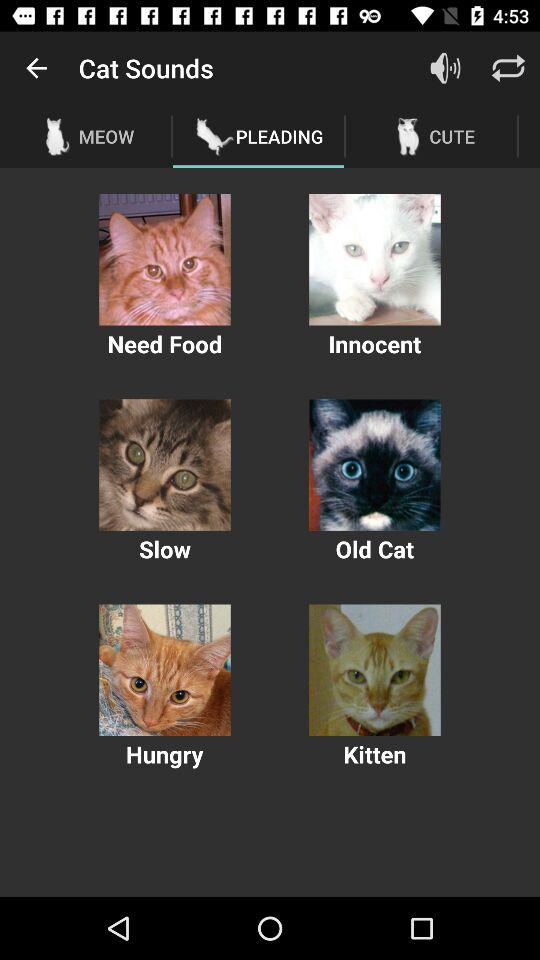How many angry cats are there?
When the provided information is insufficient, respond with <no answer>. <no answer> 